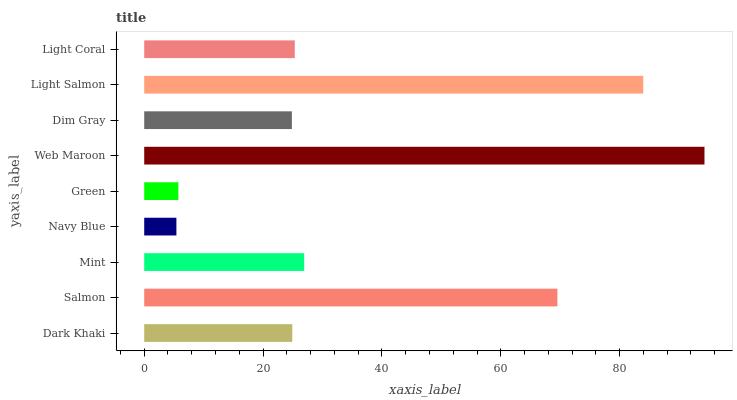Is Navy Blue the minimum?
Answer yes or no. Yes. Is Web Maroon the maximum?
Answer yes or no. Yes. Is Salmon the minimum?
Answer yes or no. No. Is Salmon the maximum?
Answer yes or no. No. Is Salmon greater than Dark Khaki?
Answer yes or no. Yes. Is Dark Khaki less than Salmon?
Answer yes or no. Yes. Is Dark Khaki greater than Salmon?
Answer yes or no. No. Is Salmon less than Dark Khaki?
Answer yes or no. No. Is Light Coral the high median?
Answer yes or no. Yes. Is Light Coral the low median?
Answer yes or no. Yes. Is Dark Khaki the high median?
Answer yes or no. No. Is Light Salmon the low median?
Answer yes or no. No. 